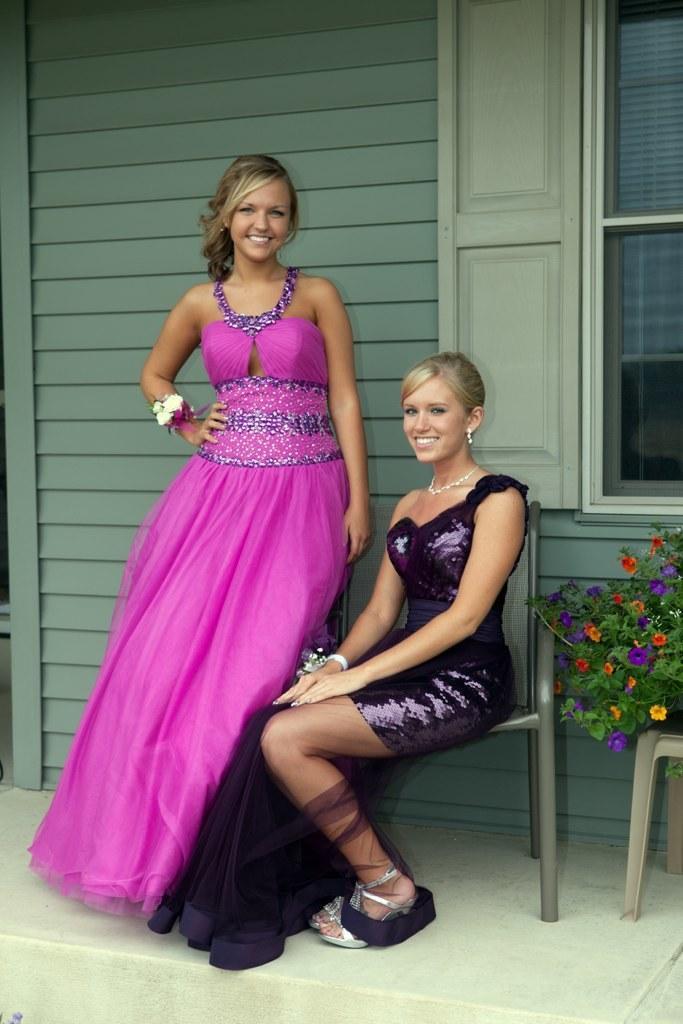Please provide a concise description of this image. In the image we can see there is woman sitting on chair and beside her there is another woman standing. Behind there is window on the wall and there are flowers on the plants. 